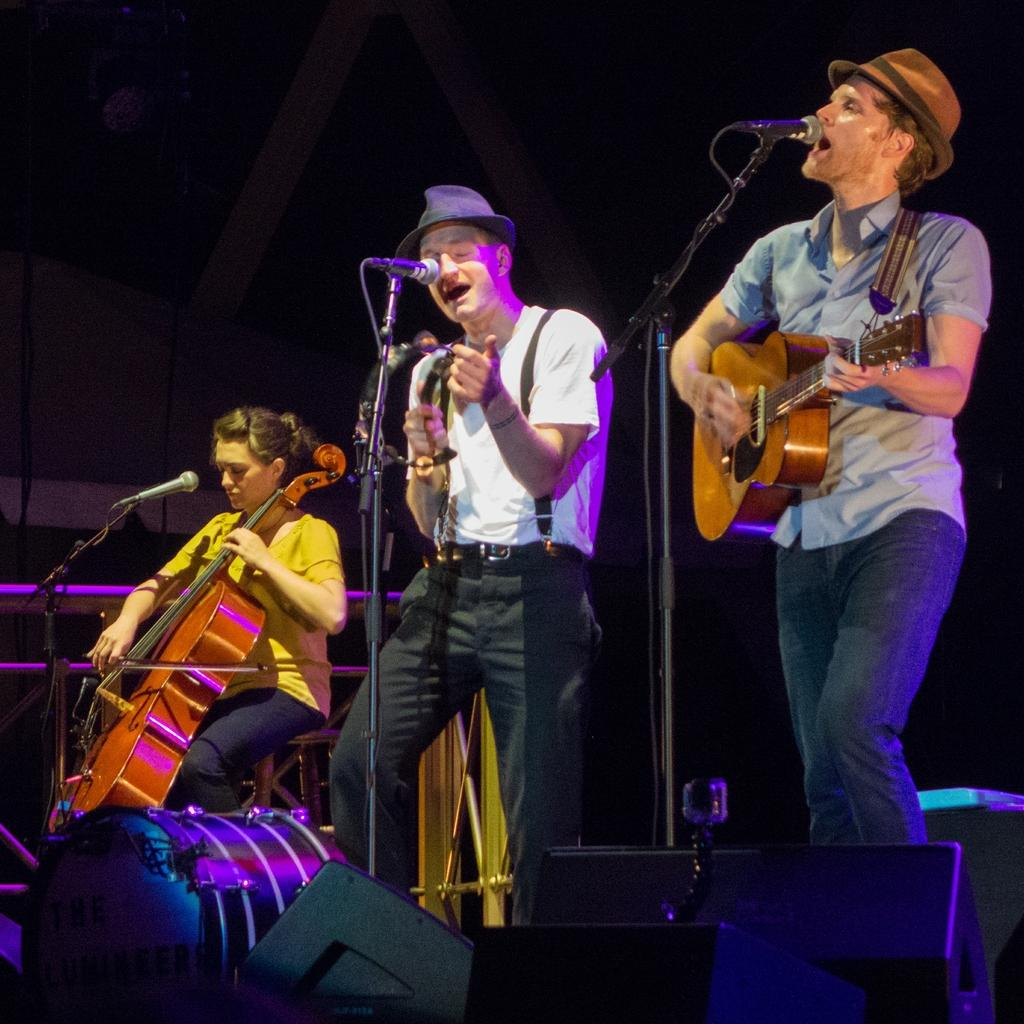How many musicians are in the image? There are three musicians in the image. What are the musicians doing in the image? The musicians are playing musical instruments. What is in front of the musicians? There is a microphone in front of the musicians. What can be seen in the background of the image? There are metal rods in the background of the image. What type of teaching is happening on the sidewalk in the image? There is no teaching or sidewalk present in the image; it features three musicians playing musical instruments with a microphone in front of them and metal rods in the background. What arithmetic problem is being solved by the musicians in the image? There is no arithmetic problem being solved by the musicians in the image; they are playing musical instruments. 